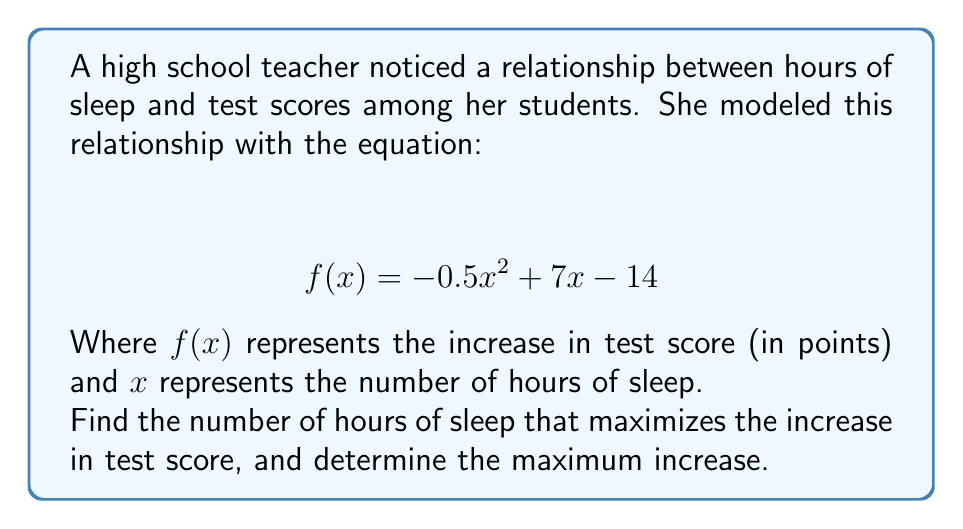Teach me how to tackle this problem. To solve this problem, we'll follow these steps:

1) The function $f(x) = -0.5x^2 + 7x - 14$ is a quadratic function. Its graph is a parabola that opens downward because the coefficient of $x^2$ is negative.

2) The maximum point of a parabola occurs at the vertex. For a quadratic function in the form $f(x) = ax^2 + bx + c$, the x-coordinate of the vertex is given by $x = -\frac{b}{2a}$.

3) In this case, $a = -0.5$ and $b = 7$. Let's calculate the x-coordinate of the vertex:

   $x = -\frac{b}{2a} = -\frac{7}{2(-0.5)} = \frac{7}{1} = 7$

4) This means that 7 hours of sleep maximizes the increase in test score.

5) To find the maximum increase, we need to calculate $f(7)$:

   $f(7) = -0.5(7)^2 + 7(7) - 14$
         $= -0.5(49) + 49 - 14$
         $= -24.5 + 49 - 14$
         $= 10.5$

Therefore, the maximum increase in test score is 10.5 points.
Answer: The number of hours of sleep that maximizes the increase in test score is 7 hours, and the maximum increase is 10.5 points. 